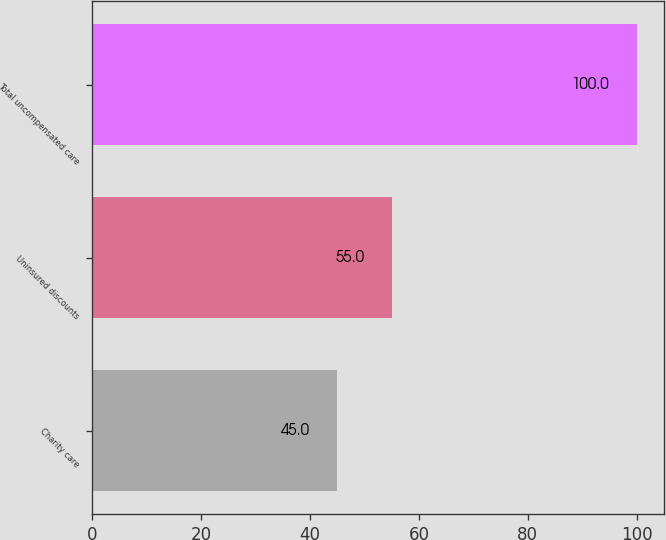<chart> <loc_0><loc_0><loc_500><loc_500><bar_chart><fcel>Charity care<fcel>Uninsured discounts<fcel>Total uncompensated care<nl><fcel>45<fcel>55<fcel>100<nl></chart> 